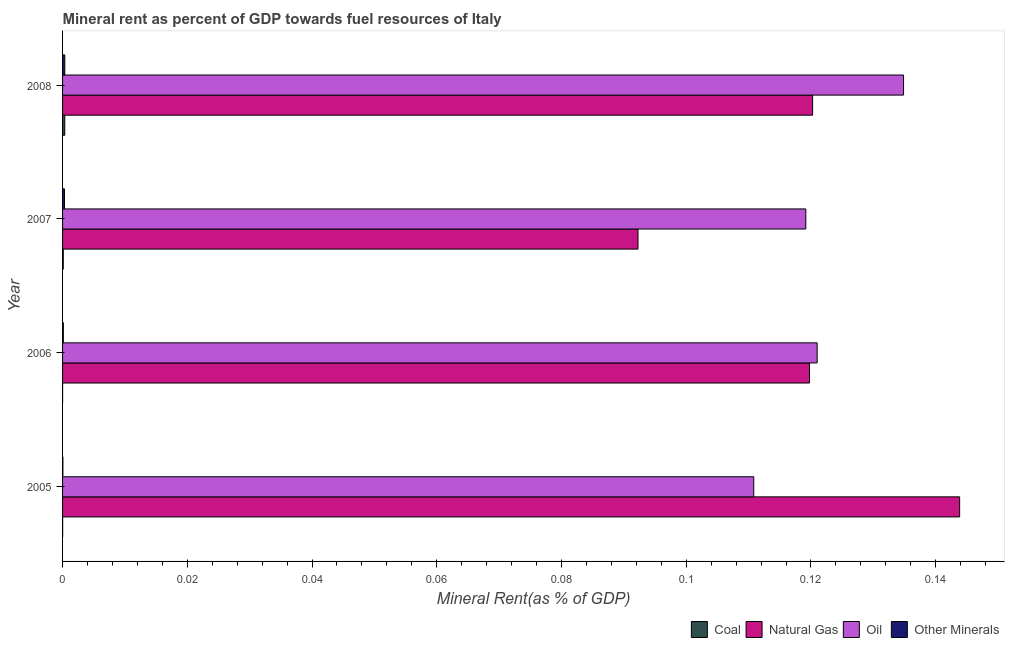How many groups of bars are there?
Your answer should be very brief. 4. Are the number of bars on each tick of the Y-axis equal?
Ensure brevity in your answer.  Yes. How many bars are there on the 2nd tick from the top?
Your response must be concise. 4. In how many cases, is the number of bars for a given year not equal to the number of legend labels?
Keep it short and to the point. 0. What is the  rent of other minerals in 2007?
Make the answer very short. 0. Across all years, what is the maximum oil rent?
Keep it short and to the point. 0.13. Across all years, what is the minimum natural gas rent?
Offer a terse response. 0.09. What is the total oil rent in the graph?
Keep it short and to the point. 0.49. What is the difference between the coal rent in 2005 and that in 2006?
Your answer should be compact. 0. What is the difference between the oil rent in 2007 and the natural gas rent in 2006?
Ensure brevity in your answer.  -0. What is the average  rent of other minerals per year?
Offer a very short reply. 0. In the year 2005, what is the difference between the natural gas rent and coal rent?
Ensure brevity in your answer.  0.14. In how many years, is the coal rent greater than 0.124 %?
Make the answer very short. 0. What is the ratio of the  rent of other minerals in 2005 to that in 2007?
Your answer should be compact. 0.17. What is the difference between the highest and the second highest  rent of other minerals?
Your response must be concise. 0. What is the difference between the highest and the lowest oil rent?
Make the answer very short. 0.02. What does the 3rd bar from the top in 2005 represents?
Give a very brief answer. Natural Gas. What does the 3rd bar from the bottom in 2008 represents?
Keep it short and to the point. Oil. How many years are there in the graph?
Offer a terse response. 4. Are the values on the major ticks of X-axis written in scientific E-notation?
Ensure brevity in your answer.  No. Does the graph contain grids?
Make the answer very short. No. Where does the legend appear in the graph?
Provide a short and direct response. Bottom right. How many legend labels are there?
Provide a succinct answer. 4. What is the title of the graph?
Give a very brief answer. Mineral rent as percent of GDP towards fuel resources of Italy. Does "Taxes on income" appear as one of the legend labels in the graph?
Provide a succinct answer. No. What is the label or title of the X-axis?
Ensure brevity in your answer.  Mineral Rent(as % of GDP). What is the Mineral Rent(as % of GDP) of Coal in 2005?
Provide a succinct answer. 1.52938665315344e-5. What is the Mineral Rent(as % of GDP) in Natural Gas in 2005?
Offer a terse response. 0.14. What is the Mineral Rent(as % of GDP) of Oil in 2005?
Ensure brevity in your answer.  0.11. What is the Mineral Rent(as % of GDP) in Other Minerals in 2005?
Your response must be concise. 5.19978483060913e-5. What is the Mineral Rent(as % of GDP) of Coal in 2006?
Your answer should be very brief. 5.16849671469394e-6. What is the Mineral Rent(as % of GDP) in Natural Gas in 2006?
Your answer should be compact. 0.12. What is the Mineral Rent(as % of GDP) in Oil in 2006?
Offer a terse response. 0.12. What is the Mineral Rent(as % of GDP) of Other Minerals in 2006?
Your response must be concise. 0. What is the Mineral Rent(as % of GDP) in Coal in 2007?
Make the answer very short. 0. What is the Mineral Rent(as % of GDP) of Natural Gas in 2007?
Offer a terse response. 0.09. What is the Mineral Rent(as % of GDP) in Oil in 2007?
Give a very brief answer. 0.12. What is the Mineral Rent(as % of GDP) of Other Minerals in 2007?
Keep it short and to the point. 0. What is the Mineral Rent(as % of GDP) in Coal in 2008?
Make the answer very short. 0. What is the Mineral Rent(as % of GDP) in Natural Gas in 2008?
Your response must be concise. 0.12. What is the Mineral Rent(as % of GDP) of Oil in 2008?
Give a very brief answer. 0.13. What is the Mineral Rent(as % of GDP) in Other Minerals in 2008?
Make the answer very short. 0. Across all years, what is the maximum Mineral Rent(as % of GDP) of Coal?
Ensure brevity in your answer.  0. Across all years, what is the maximum Mineral Rent(as % of GDP) in Natural Gas?
Your answer should be compact. 0.14. Across all years, what is the maximum Mineral Rent(as % of GDP) in Oil?
Make the answer very short. 0.13. Across all years, what is the maximum Mineral Rent(as % of GDP) of Other Minerals?
Offer a terse response. 0. Across all years, what is the minimum Mineral Rent(as % of GDP) in Coal?
Make the answer very short. 5.16849671469394e-6. Across all years, what is the minimum Mineral Rent(as % of GDP) in Natural Gas?
Offer a terse response. 0.09. Across all years, what is the minimum Mineral Rent(as % of GDP) of Oil?
Offer a very short reply. 0.11. Across all years, what is the minimum Mineral Rent(as % of GDP) in Other Minerals?
Offer a very short reply. 5.19978483060913e-5. What is the total Mineral Rent(as % of GDP) of Coal in the graph?
Make the answer very short. 0. What is the total Mineral Rent(as % of GDP) in Natural Gas in the graph?
Give a very brief answer. 0.48. What is the total Mineral Rent(as % of GDP) of Oil in the graph?
Give a very brief answer. 0.49. What is the total Mineral Rent(as % of GDP) in Other Minerals in the graph?
Your response must be concise. 0. What is the difference between the Mineral Rent(as % of GDP) of Natural Gas in 2005 and that in 2006?
Offer a terse response. 0.02. What is the difference between the Mineral Rent(as % of GDP) in Oil in 2005 and that in 2006?
Make the answer very short. -0.01. What is the difference between the Mineral Rent(as % of GDP) in Other Minerals in 2005 and that in 2006?
Give a very brief answer. -0. What is the difference between the Mineral Rent(as % of GDP) of Coal in 2005 and that in 2007?
Offer a very short reply. -0. What is the difference between the Mineral Rent(as % of GDP) in Natural Gas in 2005 and that in 2007?
Offer a terse response. 0.05. What is the difference between the Mineral Rent(as % of GDP) of Oil in 2005 and that in 2007?
Give a very brief answer. -0.01. What is the difference between the Mineral Rent(as % of GDP) in Other Minerals in 2005 and that in 2007?
Your answer should be very brief. -0. What is the difference between the Mineral Rent(as % of GDP) of Coal in 2005 and that in 2008?
Your answer should be compact. -0. What is the difference between the Mineral Rent(as % of GDP) in Natural Gas in 2005 and that in 2008?
Keep it short and to the point. 0.02. What is the difference between the Mineral Rent(as % of GDP) in Oil in 2005 and that in 2008?
Provide a short and direct response. -0.02. What is the difference between the Mineral Rent(as % of GDP) in Other Minerals in 2005 and that in 2008?
Provide a succinct answer. -0. What is the difference between the Mineral Rent(as % of GDP) in Coal in 2006 and that in 2007?
Ensure brevity in your answer.  -0. What is the difference between the Mineral Rent(as % of GDP) of Natural Gas in 2006 and that in 2007?
Make the answer very short. 0.03. What is the difference between the Mineral Rent(as % of GDP) in Oil in 2006 and that in 2007?
Give a very brief answer. 0. What is the difference between the Mineral Rent(as % of GDP) of Other Minerals in 2006 and that in 2007?
Your answer should be very brief. -0. What is the difference between the Mineral Rent(as % of GDP) in Coal in 2006 and that in 2008?
Provide a short and direct response. -0. What is the difference between the Mineral Rent(as % of GDP) of Natural Gas in 2006 and that in 2008?
Make the answer very short. -0. What is the difference between the Mineral Rent(as % of GDP) in Oil in 2006 and that in 2008?
Your answer should be compact. -0.01. What is the difference between the Mineral Rent(as % of GDP) in Other Minerals in 2006 and that in 2008?
Give a very brief answer. -0. What is the difference between the Mineral Rent(as % of GDP) of Coal in 2007 and that in 2008?
Give a very brief answer. -0. What is the difference between the Mineral Rent(as % of GDP) in Natural Gas in 2007 and that in 2008?
Offer a terse response. -0.03. What is the difference between the Mineral Rent(as % of GDP) in Oil in 2007 and that in 2008?
Your response must be concise. -0.02. What is the difference between the Mineral Rent(as % of GDP) of Other Minerals in 2007 and that in 2008?
Ensure brevity in your answer.  -0. What is the difference between the Mineral Rent(as % of GDP) in Coal in 2005 and the Mineral Rent(as % of GDP) in Natural Gas in 2006?
Offer a terse response. -0.12. What is the difference between the Mineral Rent(as % of GDP) of Coal in 2005 and the Mineral Rent(as % of GDP) of Oil in 2006?
Make the answer very short. -0.12. What is the difference between the Mineral Rent(as % of GDP) in Coal in 2005 and the Mineral Rent(as % of GDP) in Other Minerals in 2006?
Provide a short and direct response. -0. What is the difference between the Mineral Rent(as % of GDP) of Natural Gas in 2005 and the Mineral Rent(as % of GDP) of Oil in 2006?
Keep it short and to the point. 0.02. What is the difference between the Mineral Rent(as % of GDP) in Natural Gas in 2005 and the Mineral Rent(as % of GDP) in Other Minerals in 2006?
Provide a short and direct response. 0.14. What is the difference between the Mineral Rent(as % of GDP) of Oil in 2005 and the Mineral Rent(as % of GDP) of Other Minerals in 2006?
Keep it short and to the point. 0.11. What is the difference between the Mineral Rent(as % of GDP) in Coal in 2005 and the Mineral Rent(as % of GDP) in Natural Gas in 2007?
Ensure brevity in your answer.  -0.09. What is the difference between the Mineral Rent(as % of GDP) in Coal in 2005 and the Mineral Rent(as % of GDP) in Oil in 2007?
Offer a very short reply. -0.12. What is the difference between the Mineral Rent(as % of GDP) of Coal in 2005 and the Mineral Rent(as % of GDP) of Other Minerals in 2007?
Ensure brevity in your answer.  -0. What is the difference between the Mineral Rent(as % of GDP) in Natural Gas in 2005 and the Mineral Rent(as % of GDP) in Oil in 2007?
Give a very brief answer. 0.02. What is the difference between the Mineral Rent(as % of GDP) in Natural Gas in 2005 and the Mineral Rent(as % of GDP) in Other Minerals in 2007?
Keep it short and to the point. 0.14. What is the difference between the Mineral Rent(as % of GDP) of Oil in 2005 and the Mineral Rent(as % of GDP) of Other Minerals in 2007?
Your response must be concise. 0.11. What is the difference between the Mineral Rent(as % of GDP) in Coal in 2005 and the Mineral Rent(as % of GDP) in Natural Gas in 2008?
Make the answer very short. -0.12. What is the difference between the Mineral Rent(as % of GDP) of Coal in 2005 and the Mineral Rent(as % of GDP) of Oil in 2008?
Offer a terse response. -0.13. What is the difference between the Mineral Rent(as % of GDP) in Coal in 2005 and the Mineral Rent(as % of GDP) in Other Minerals in 2008?
Your answer should be very brief. -0. What is the difference between the Mineral Rent(as % of GDP) of Natural Gas in 2005 and the Mineral Rent(as % of GDP) of Oil in 2008?
Provide a succinct answer. 0.01. What is the difference between the Mineral Rent(as % of GDP) of Natural Gas in 2005 and the Mineral Rent(as % of GDP) of Other Minerals in 2008?
Ensure brevity in your answer.  0.14. What is the difference between the Mineral Rent(as % of GDP) in Oil in 2005 and the Mineral Rent(as % of GDP) in Other Minerals in 2008?
Provide a succinct answer. 0.11. What is the difference between the Mineral Rent(as % of GDP) in Coal in 2006 and the Mineral Rent(as % of GDP) in Natural Gas in 2007?
Your answer should be very brief. -0.09. What is the difference between the Mineral Rent(as % of GDP) in Coal in 2006 and the Mineral Rent(as % of GDP) in Oil in 2007?
Your answer should be compact. -0.12. What is the difference between the Mineral Rent(as % of GDP) in Coal in 2006 and the Mineral Rent(as % of GDP) in Other Minerals in 2007?
Offer a very short reply. -0. What is the difference between the Mineral Rent(as % of GDP) in Natural Gas in 2006 and the Mineral Rent(as % of GDP) in Oil in 2007?
Give a very brief answer. 0. What is the difference between the Mineral Rent(as % of GDP) in Natural Gas in 2006 and the Mineral Rent(as % of GDP) in Other Minerals in 2007?
Provide a succinct answer. 0.12. What is the difference between the Mineral Rent(as % of GDP) of Oil in 2006 and the Mineral Rent(as % of GDP) of Other Minerals in 2007?
Make the answer very short. 0.12. What is the difference between the Mineral Rent(as % of GDP) in Coal in 2006 and the Mineral Rent(as % of GDP) in Natural Gas in 2008?
Offer a terse response. -0.12. What is the difference between the Mineral Rent(as % of GDP) of Coal in 2006 and the Mineral Rent(as % of GDP) of Oil in 2008?
Your response must be concise. -0.13. What is the difference between the Mineral Rent(as % of GDP) in Coal in 2006 and the Mineral Rent(as % of GDP) in Other Minerals in 2008?
Make the answer very short. -0. What is the difference between the Mineral Rent(as % of GDP) in Natural Gas in 2006 and the Mineral Rent(as % of GDP) in Oil in 2008?
Your answer should be compact. -0.02. What is the difference between the Mineral Rent(as % of GDP) of Natural Gas in 2006 and the Mineral Rent(as % of GDP) of Other Minerals in 2008?
Ensure brevity in your answer.  0.12. What is the difference between the Mineral Rent(as % of GDP) in Oil in 2006 and the Mineral Rent(as % of GDP) in Other Minerals in 2008?
Keep it short and to the point. 0.12. What is the difference between the Mineral Rent(as % of GDP) of Coal in 2007 and the Mineral Rent(as % of GDP) of Natural Gas in 2008?
Give a very brief answer. -0.12. What is the difference between the Mineral Rent(as % of GDP) in Coal in 2007 and the Mineral Rent(as % of GDP) in Oil in 2008?
Offer a very short reply. -0.13. What is the difference between the Mineral Rent(as % of GDP) of Coal in 2007 and the Mineral Rent(as % of GDP) of Other Minerals in 2008?
Offer a very short reply. -0. What is the difference between the Mineral Rent(as % of GDP) of Natural Gas in 2007 and the Mineral Rent(as % of GDP) of Oil in 2008?
Your response must be concise. -0.04. What is the difference between the Mineral Rent(as % of GDP) in Natural Gas in 2007 and the Mineral Rent(as % of GDP) in Other Minerals in 2008?
Your answer should be very brief. 0.09. What is the difference between the Mineral Rent(as % of GDP) in Oil in 2007 and the Mineral Rent(as % of GDP) in Other Minerals in 2008?
Your response must be concise. 0.12. What is the average Mineral Rent(as % of GDP) of Coal per year?
Your answer should be compact. 0. What is the average Mineral Rent(as % of GDP) in Natural Gas per year?
Offer a terse response. 0.12. What is the average Mineral Rent(as % of GDP) in Oil per year?
Offer a very short reply. 0.12. In the year 2005, what is the difference between the Mineral Rent(as % of GDP) in Coal and Mineral Rent(as % of GDP) in Natural Gas?
Provide a succinct answer. -0.14. In the year 2005, what is the difference between the Mineral Rent(as % of GDP) of Coal and Mineral Rent(as % of GDP) of Oil?
Ensure brevity in your answer.  -0.11. In the year 2005, what is the difference between the Mineral Rent(as % of GDP) of Natural Gas and Mineral Rent(as % of GDP) of Oil?
Your answer should be very brief. 0.03. In the year 2005, what is the difference between the Mineral Rent(as % of GDP) of Natural Gas and Mineral Rent(as % of GDP) of Other Minerals?
Your response must be concise. 0.14. In the year 2005, what is the difference between the Mineral Rent(as % of GDP) of Oil and Mineral Rent(as % of GDP) of Other Minerals?
Your response must be concise. 0.11. In the year 2006, what is the difference between the Mineral Rent(as % of GDP) in Coal and Mineral Rent(as % of GDP) in Natural Gas?
Ensure brevity in your answer.  -0.12. In the year 2006, what is the difference between the Mineral Rent(as % of GDP) of Coal and Mineral Rent(as % of GDP) of Oil?
Offer a terse response. -0.12. In the year 2006, what is the difference between the Mineral Rent(as % of GDP) of Coal and Mineral Rent(as % of GDP) of Other Minerals?
Keep it short and to the point. -0. In the year 2006, what is the difference between the Mineral Rent(as % of GDP) of Natural Gas and Mineral Rent(as % of GDP) of Oil?
Offer a terse response. -0. In the year 2006, what is the difference between the Mineral Rent(as % of GDP) of Natural Gas and Mineral Rent(as % of GDP) of Other Minerals?
Offer a terse response. 0.12. In the year 2006, what is the difference between the Mineral Rent(as % of GDP) of Oil and Mineral Rent(as % of GDP) of Other Minerals?
Make the answer very short. 0.12. In the year 2007, what is the difference between the Mineral Rent(as % of GDP) of Coal and Mineral Rent(as % of GDP) of Natural Gas?
Your response must be concise. -0.09. In the year 2007, what is the difference between the Mineral Rent(as % of GDP) in Coal and Mineral Rent(as % of GDP) in Oil?
Offer a very short reply. -0.12. In the year 2007, what is the difference between the Mineral Rent(as % of GDP) of Coal and Mineral Rent(as % of GDP) of Other Minerals?
Your answer should be compact. -0. In the year 2007, what is the difference between the Mineral Rent(as % of GDP) in Natural Gas and Mineral Rent(as % of GDP) in Oil?
Your answer should be compact. -0.03. In the year 2007, what is the difference between the Mineral Rent(as % of GDP) in Natural Gas and Mineral Rent(as % of GDP) in Other Minerals?
Keep it short and to the point. 0.09. In the year 2007, what is the difference between the Mineral Rent(as % of GDP) of Oil and Mineral Rent(as % of GDP) of Other Minerals?
Provide a short and direct response. 0.12. In the year 2008, what is the difference between the Mineral Rent(as % of GDP) in Coal and Mineral Rent(as % of GDP) in Natural Gas?
Keep it short and to the point. -0.12. In the year 2008, what is the difference between the Mineral Rent(as % of GDP) in Coal and Mineral Rent(as % of GDP) in Oil?
Your answer should be compact. -0.13. In the year 2008, what is the difference between the Mineral Rent(as % of GDP) of Coal and Mineral Rent(as % of GDP) of Other Minerals?
Your response must be concise. -0. In the year 2008, what is the difference between the Mineral Rent(as % of GDP) of Natural Gas and Mineral Rent(as % of GDP) of Oil?
Make the answer very short. -0.01. In the year 2008, what is the difference between the Mineral Rent(as % of GDP) of Natural Gas and Mineral Rent(as % of GDP) of Other Minerals?
Your answer should be very brief. 0.12. In the year 2008, what is the difference between the Mineral Rent(as % of GDP) in Oil and Mineral Rent(as % of GDP) in Other Minerals?
Offer a terse response. 0.13. What is the ratio of the Mineral Rent(as % of GDP) in Coal in 2005 to that in 2006?
Keep it short and to the point. 2.96. What is the ratio of the Mineral Rent(as % of GDP) of Natural Gas in 2005 to that in 2006?
Provide a succinct answer. 1.2. What is the ratio of the Mineral Rent(as % of GDP) in Oil in 2005 to that in 2006?
Offer a very short reply. 0.92. What is the ratio of the Mineral Rent(as % of GDP) in Other Minerals in 2005 to that in 2006?
Offer a terse response. 0.42. What is the ratio of the Mineral Rent(as % of GDP) of Coal in 2005 to that in 2007?
Your answer should be compact. 0.14. What is the ratio of the Mineral Rent(as % of GDP) in Natural Gas in 2005 to that in 2007?
Give a very brief answer. 1.56. What is the ratio of the Mineral Rent(as % of GDP) of Other Minerals in 2005 to that in 2007?
Your response must be concise. 0.17. What is the ratio of the Mineral Rent(as % of GDP) of Coal in 2005 to that in 2008?
Offer a very short reply. 0.04. What is the ratio of the Mineral Rent(as % of GDP) of Natural Gas in 2005 to that in 2008?
Your answer should be very brief. 1.2. What is the ratio of the Mineral Rent(as % of GDP) of Oil in 2005 to that in 2008?
Give a very brief answer. 0.82. What is the ratio of the Mineral Rent(as % of GDP) of Other Minerals in 2005 to that in 2008?
Ensure brevity in your answer.  0.15. What is the ratio of the Mineral Rent(as % of GDP) in Coal in 2006 to that in 2007?
Ensure brevity in your answer.  0.05. What is the ratio of the Mineral Rent(as % of GDP) in Natural Gas in 2006 to that in 2007?
Provide a succinct answer. 1.3. What is the ratio of the Mineral Rent(as % of GDP) of Oil in 2006 to that in 2007?
Offer a terse response. 1.02. What is the ratio of the Mineral Rent(as % of GDP) in Other Minerals in 2006 to that in 2007?
Offer a very short reply. 0.4. What is the ratio of the Mineral Rent(as % of GDP) of Coal in 2006 to that in 2008?
Your answer should be compact. 0.01. What is the ratio of the Mineral Rent(as % of GDP) in Oil in 2006 to that in 2008?
Make the answer very short. 0.9. What is the ratio of the Mineral Rent(as % of GDP) of Other Minerals in 2006 to that in 2008?
Offer a terse response. 0.35. What is the ratio of the Mineral Rent(as % of GDP) of Coal in 2007 to that in 2008?
Keep it short and to the point. 0.32. What is the ratio of the Mineral Rent(as % of GDP) of Natural Gas in 2007 to that in 2008?
Offer a very short reply. 0.77. What is the ratio of the Mineral Rent(as % of GDP) in Oil in 2007 to that in 2008?
Your response must be concise. 0.88. What is the ratio of the Mineral Rent(as % of GDP) of Other Minerals in 2007 to that in 2008?
Ensure brevity in your answer.  0.87. What is the difference between the highest and the second highest Mineral Rent(as % of GDP) of Natural Gas?
Provide a short and direct response. 0.02. What is the difference between the highest and the second highest Mineral Rent(as % of GDP) in Oil?
Your answer should be compact. 0.01. What is the difference between the highest and the second highest Mineral Rent(as % of GDP) in Other Minerals?
Offer a terse response. 0. What is the difference between the highest and the lowest Mineral Rent(as % of GDP) of Coal?
Offer a very short reply. 0. What is the difference between the highest and the lowest Mineral Rent(as % of GDP) of Natural Gas?
Your response must be concise. 0.05. What is the difference between the highest and the lowest Mineral Rent(as % of GDP) of Oil?
Make the answer very short. 0.02. What is the difference between the highest and the lowest Mineral Rent(as % of GDP) of Other Minerals?
Give a very brief answer. 0. 